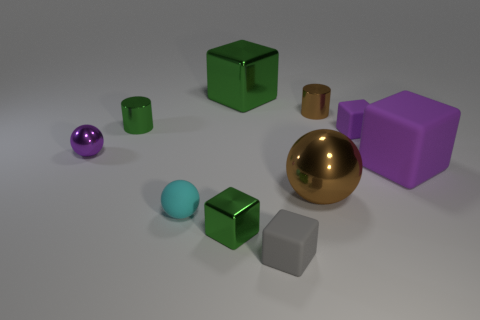Subtract 2 cubes. How many cubes are left? 3 Subtract all shiny cubes. How many cubes are left? 3 Subtract all green cubes. How many cubes are left? 3 Subtract all spheres. How many objects are left? 7 Subtract all tiny purple shiny spheres. Subtract all cyan rubber balls. How many objects are left? 8 Add 8 tiny gray things. How many tiny gray things are left? 9 Add 8 brown cylinders. How many brown cylinders exist? 9 Subtract 1 green cubes. How many objects are left? 9 Subtract all brown cylinders. Subtract all yellow balls. How many cylinders are left? 1 